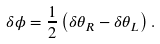<formula> <loc_0><loc_0><loc_500><loc_500>\delta \phi = \frac { 1 } { 2 } \left ( \delta \theta _ { R } - \delta \theta _ { L } \right ) .</formula> 